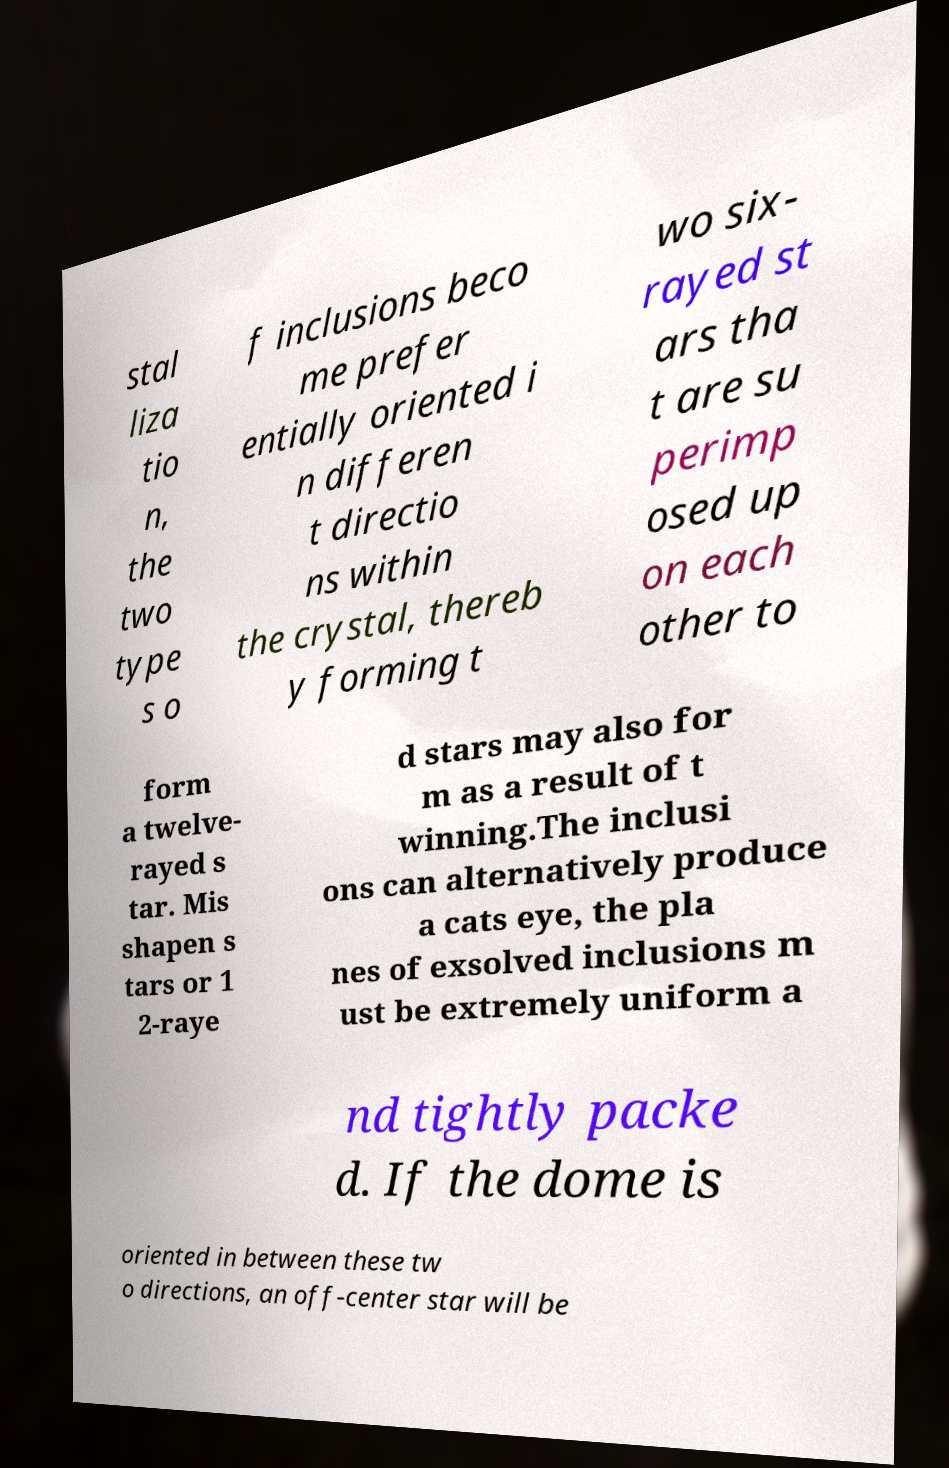Please read and relay the text visible in this image. What does it say? stal liza tio n, the two type s o f inclusions beco me prefer entially oriented i n differen t directio ns within the crystal, thereb y forming t wo six- rayed st ars tha t are su perimp osed up on each other to form a twelve- rayed s tar. Mis shapen s tars or 1 2-raye d stars may also for m as a result of t winning.The inclusi ons can alternatively produce a cats eye, the pla nes of exsolved inclusions m ust be extremely uniform a nd tightly packe d. If the dome is oriented in between these tw o directions, an off-center star will be 